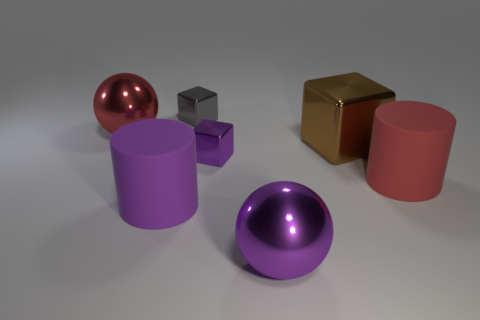There is a purple metallic ball; are there any purple cylinders to the left of it?
Your response must be concise. Yes. There is a big purple object that is to the left of the gray cube; is there a large purple rubber thing that is to the left of it?
Give a very brief answer. No. Is the size of the red object in front of the large brown metallic block the same as the ball that is behind the large purple matte object?
Your response must be concise. Yes. How many big things are either red things or brown metal cylinders?
Make the answer very short. 2. The tiny cube that is behind the sphere left of the large purple metallic object is made of what material?
Your response must be concise. Metal. Are there any red cylinders that have the same material as the big brown block?
Provide a short and direct response. No. Do the big purple sphere and the cylinder that is behind the large purple cylinder have the same material?
Provide a short and direct response. No. What color is the metal thing that is the same size as the gray metal cube?
Offer a very short reply. Purple. There is a purple thing that is behind the large matte cylinder that is behind the big purple matte object; how big is it?
Offer a very short reply. Small. Is the number of tiny purple metal objects on the right side of the tiny purple shiny object less than the number of big red metal objects?
Make the answer very short. Yes. 